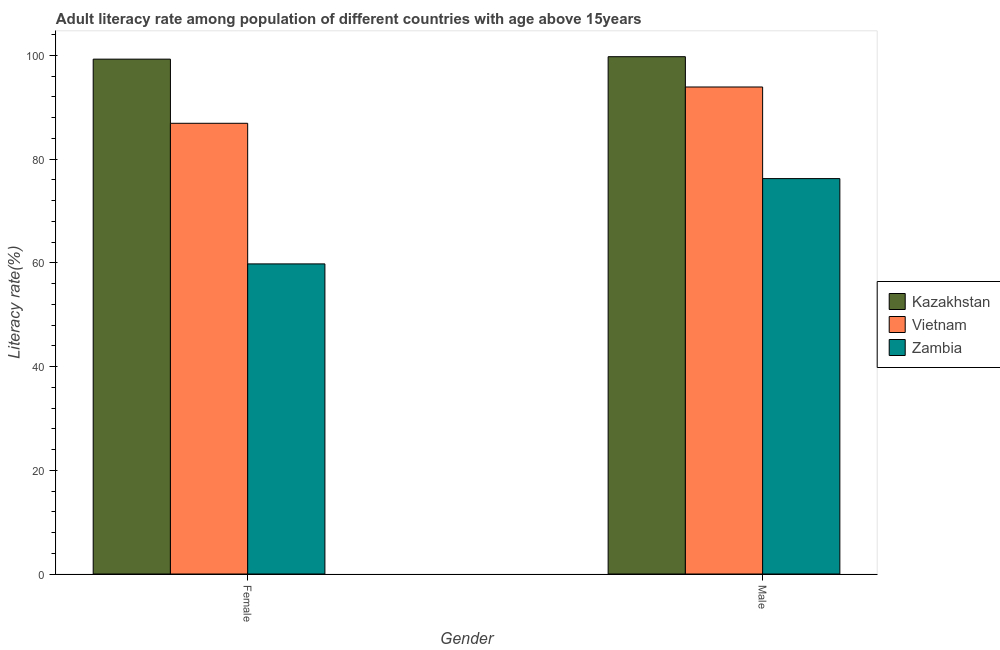How many different coloured bars are there?
Make the answer very short. 3. How many groups of bars are there?
Offer a terse response. 2. How many bars are there on the 2nd tick from the right?
Ensure brevity in your answer.  3. What is the label of the 1st group of bars from the left?
Provide a succinct answer. Female. What is the male adult literacy rate in Zambia?
Provide a short and direct response. 76.25. Across all countries, what is the maximum female adult literacy rate?
Keep it short and to the point. 99.29. Across all countries, what is the minimum male adult literacy rate?
Your response must be concise. 76.25. In which country was the male adult literacy rate maximum?
Give a very brief answer. Kazakhstan. In which country was the male adult literacy rate minimum?
Offer a terse response. Zambia. What is the total female adult literacy rate in the graph?
Offer a terse response. 246.01. What is the difference between the male adult literacy rate in Vietnam and that in Kazakhstan?
Keep it short and to the point. -5.85. What is the difference between the male adult literacy rate in Kazakhstan and the female adult literacy rate in Vietnam?
Offer a terse response. 12.84. What is the average female adult literacy rate per country?
Your response must be concise. 82. What is the difference between the male adult literacy rate and female adult literacy rate in Kazakhstan?
Your answer should be very brief. 0.47. What is the ratio of the female adult literacy rate in Kazakhstan to that in Vietnam?
Ensure brevity in your answer.  1.14. What does the 2nd bar from the left in Male represents?
Your response must be concise. Vietnam. What does the 2nd bar from the right in Female represents?
Your answer should be compact. Vietnam. How many bars are there?
Make the answer very short. 6. Are all the bars in the graph horizontal?
Give a very brief answer. No. How many countries are there in the graph?
Make the answer very short. 3. Are the values on the major ticks of Y-axis written in scientific E-notation?
Your answer should be very brief. No. Does the graph contain grids?
Provide a succinct answer. No. Where does the legend appear in the graph?
Your answer should be compact. Center right. How are the legend labels stacked?
Make the answer very short. Vertical. What is the title of the graph?
Your answer should be compact. Adult literacy rate among population of different countries with age above 15years. What is the label or title of the X-axis?
Your response must be concise. Gender. What is the label or title of the Y-axis?
Make the answer very short. Literacy rate(%). What is the Literacy rate(%) in Kazakhstan in Female?
Offer a terse response. 99.29. What is the Literacy rate(%) of Vietnam in Female?
Keep it short and to the point. 86.92. What is the Literacy rate(%) of Zambia in Female?
Your response must be concise. 59.8. What is the Literacy rate(%) in Kazakhstan in Male?
Give a very brief answer. 99.76. What is the Literacy rate(%) in Vietnam in Male?
Ensure brevity in your answer.  93.92. What is the Literacy rate(%) of Zambia in Male?
Your answer should be compact. 76.25. Across all Gender, what is the maximum Literacy rate(%) in Kazakhstan?
Ensure brevity in your answer.  99.76. Across all Gender, what is the maximum Literacy rate(%) in Vietnam?
Provide a succinct answer. 93.92. Across all Gender, what is the maximum Literacy rate(%) in Zambia?
Your answer should be compact. 76.25. Across all Gender, what is the minimum Literacy rate(%) in Kazakhstan?
Your response must be concise. 99.29. Across all Gender, what is the minimum Literacy rate(%) of Vietnam?
Your response must be concise. 86.92. Across all Gender, what is the minimum Literacy rate(%) in Zambia?
Your response must be concise. 59.8. What is the total Literacy rate(%) of Kazakhstan in the graph?
Keep it short and to the point. 199.05. What is the total Literacy rate(%) in Vietnam in the graph?
Give a very brief answer. 180.84. What is the total Literacy rate(%) of Zambia in the graph?
Make the answer very short. 136.06. What is the difference between the Literacy rate(%) of Kazakhstan in Female and that in Male?
Ensure brevity in your answer.  -0.47. What is the difference between the Literacy rate(%) in Vietnam in Female and that in Male?
Your answer should be very brief. -7. What is the difference between the Literacy rate(%) of Zambia in Female and that in Male?
Keep it short and to the point. -16.45. What is the difference between the Literacy rate(%) of Kazakhstan in Female and the Literacy rate(%) of Vietnam in Male?
Your answer should be compact. 5.37. What is the difference between the Literacy rate(%) of Kazakhstan in Female and the Literacy rate(%) of Zambia in Male?
Offer a very short reply. 23.04. What is the difference between the Literacy rate(%) of Vietnam in Female and the Literacy rate(%) of Zambia in Male?
Your response must be concise. 10.67. What is the average Literacy rate(%) in Kazakhstan per Gender?
Offer a terse response. 99.53. What is the average Literacy rate(%) of Vietnam per Gender?
Your response must be concise. 90.42. What is the average Literacy rate(%) in Zambia per Gender?
Ensure brevity in your answer.  68.03. What is the difference between the Literacy rate(%) in Kazakhstan and Literacy rate(%) in Vietnam in Female?
Make the answer very short. 12.37. What is the difference between the Literacy rate(%) of Kazakhstan and Literacy rate(%) of Zambia in Female?
Give a very brief answer. 39.49. What is the difference between the Literacy rate(%) in Vietnam and Literacy rate(%) in Zambia in Female?
Ensure brevity in your answer.  27.12. What is the difference between the Literacy rate(%) in Kazakhstan and Literacy rate(%) in Vietnam in Male?
Offer a terse response. 5.84. What is the difference between the Literacy rate(%) of Kazakhstan and Literacy rate(%) of Zambia in Male?
Provide a succinct answer. 23.51. What is the difference between the Literacy rate(%) in Vietnam and Literacy rate(%) in Zambia in Male?
Your answer should be compact. 17.66. What is the ratio of the Literacy rate(%) in Vietnam in Female to that in Male?
Your response must be concise. 0.93. What is the ratio of the Literacy rate(%) in Zambia in Female to that in Male?
Offer a terse response. 0.78. What is the difference between the highest and the second highest Literacy rate(%) of Kazakhstan?
Your answer should be compact. 0.47. What is the difference between the highest and the second highest Literacy rate(%) in Vietnam?
Your response must be concise. 7. What is the difference between the highest and the second highest Literacy rate(%) in Zambia?
Ensure brevity in your answer.  16.45. What is the difference between the highest and the lowest Literacy rate(%) of Kazakhstan?
Ensure brevity in your answer.  0.47. What is the difference between the highest and the lowest Literacy rate(%) of Vietnam?
Your answer should be compact. 7. What is the difference between the highest and the lowest Literacy rate(%) of Zambia?
Provide a succinct answer. 16.45. 